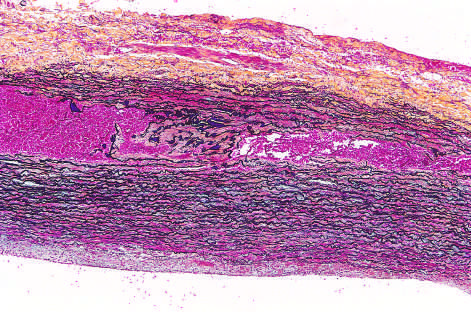s sci transl red in this section, stained with movat stain?
Answer the question using a single word or phrase. No 